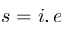<formula> <loc_0><loc_0><loc_500><loc_500>s = i , e</formula> 